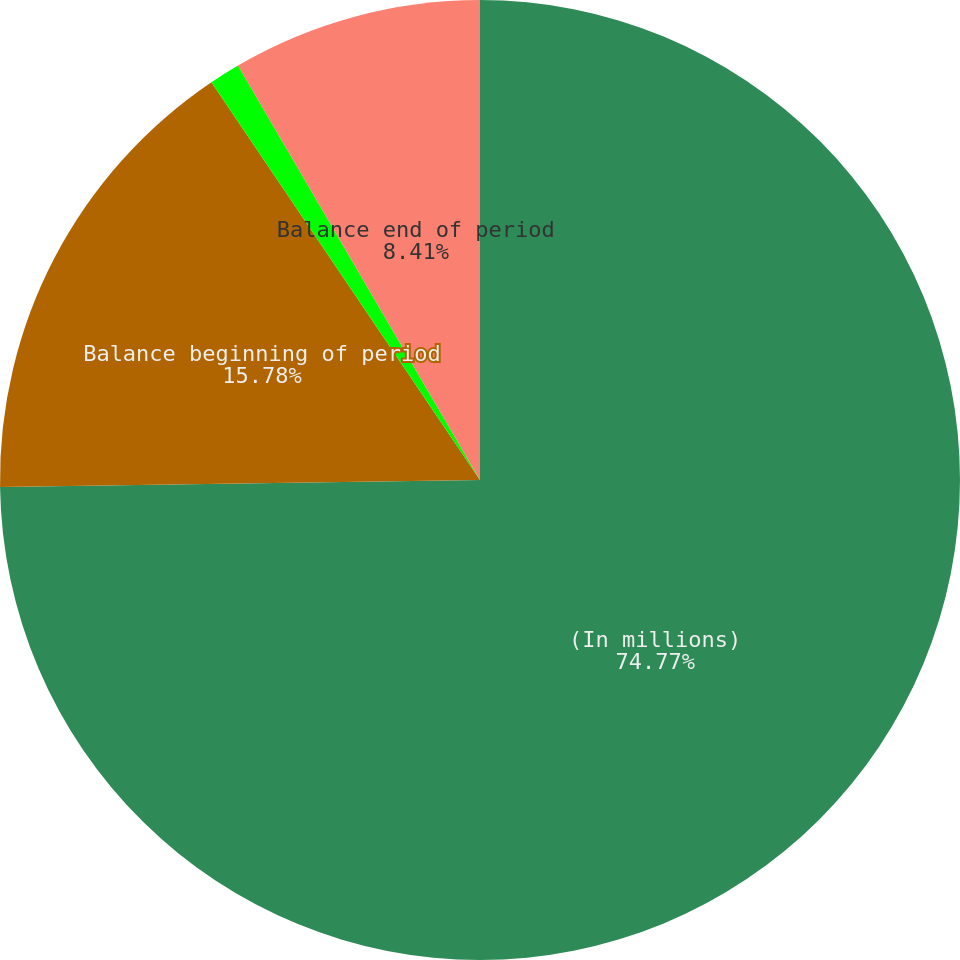<chart> <loc_0><loc_0><loc_500><loc_500><pie_chart><fcel>(In millions)<fcel>Balance beginning of period<fcel>Previously recognized losses<fcel>Balance end of period<nl><fcel>74.77%<fcel>15.78%<fcel>1.04%<fcel>8.41%<nl></chart> 